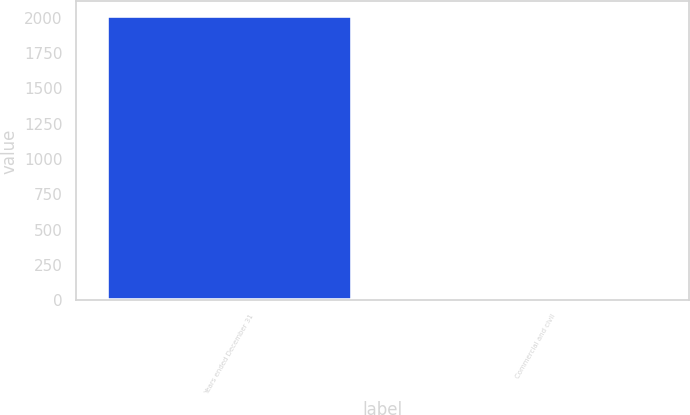Convert chart. <chart><loc_0><loc_0><loc_500><loc_500><bar_chart><fcel>Years ended December 31<fcel>Commercial and civil<nl><fcel>2014<fcel>5<nl></chart> 